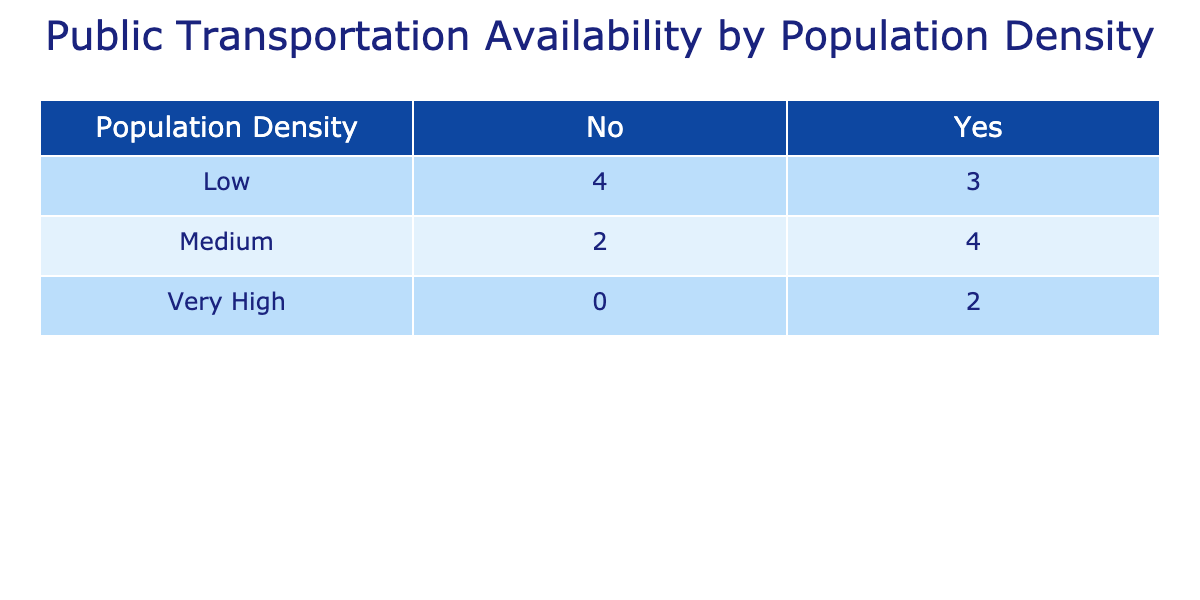What is the transport availability for counties with high population density? The high population density category includes Buncombe and Henderson, both of which have transport availability categorized as 'Yes'. Thus, both counties provide public transportation options.
Answer: Yes How many counties with medium population density have public transportation options? The medium density category includes Haywood, Transylvania, and Watauga. Out of these, Haywood and Transylvania have transport availability listed as 'Yes'. Therefore, there are two counties in medium density that offer public transportation.
Answer: 2 Which county has the lowest population density, and what is its transport availability? Graham County has the lowest population density at 25.4 persons per square mile. Its transport availability is listed as 'No', meaning there are no public transportation options available in that county.
Answer: Graham County, No If we look at counties with low population density, what percentage have public transportation options? The low density category includes Swain, Jackson, Graham, and Mitchell. Out of these four counties, only Clay County has transport availability marked as 'Yes'. Therefore, the percentage is (1/4) * 100 = 25%.
Answer: 25% How many counties have no public transportation options, and what are their population densities? The counties with no public transportation options are Madison, Jackson, Swain, Mitchell, Graham, and McDowell. Their population densities are 72.5, 120.1, 51.6, 87.4, 25.4, and 135.1 respectively.
Answer: 6 counties, [72.5, 120.1, 51.6, 87.4, 25.4, 135.1] What is the total number of counties classified as having "Very High" population density? The counties that fall into the "Very High" density category are Buncombe and Henderson. Thus, there are two counties in this classification.
Answer: 2 Among the counties listed, which one has the highest population density and what is its transport availability? Henderson County has the highest population density at 367.4 persons per square mile. Its transport availability is recorded as 'Yes', indicating there is public transportation available.
Answer: Henderson County, Yes 